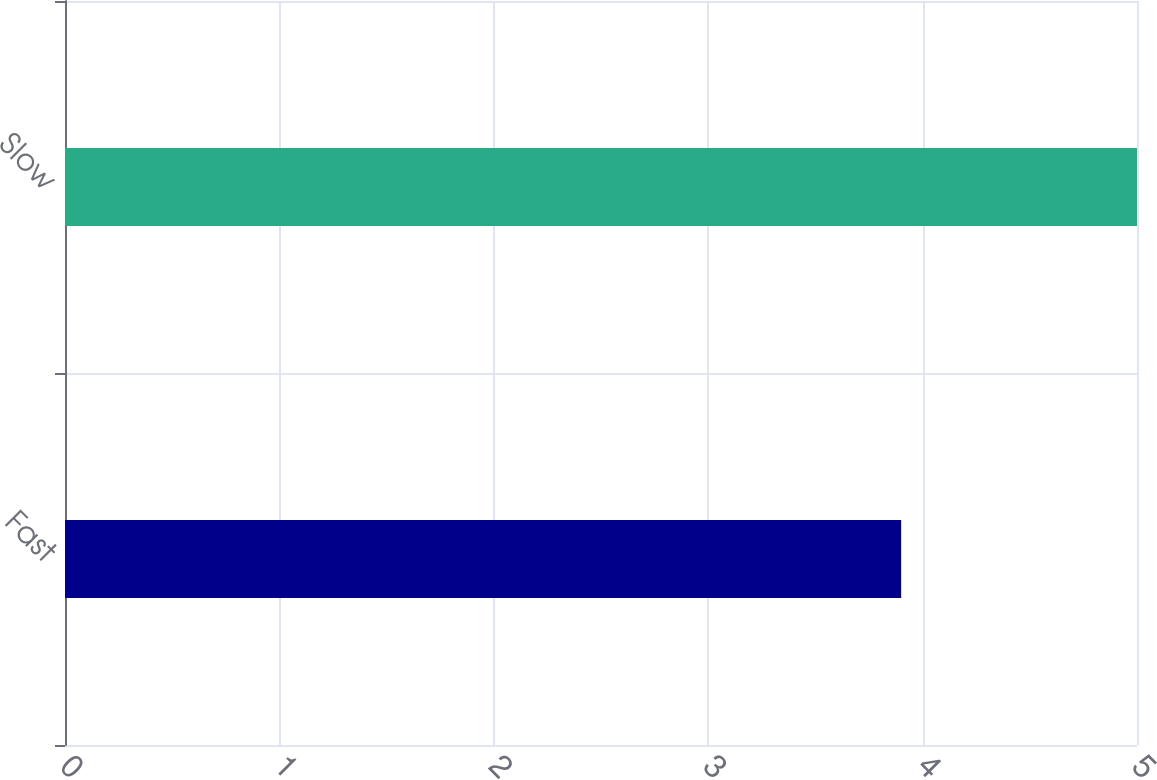<chart> <loc_0><loc_0><loc_500><loc_500><bar_chart><fcel>Fast<fcel>Slow<nl><fcel>3.9<fcel>5<nl></chart> 